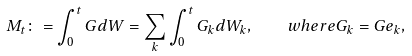<formula> <loc_0><loc_0><loc_500><loc_500>M _ { t } \colon = \int _ { 0 } ^ { t } G d W = \sum _ { k } \int _ { 0 } ^ { t } G _ { k } d W _ { k } , \quad w h e r e G _ { k } = G e _ { k } ,</formula> 